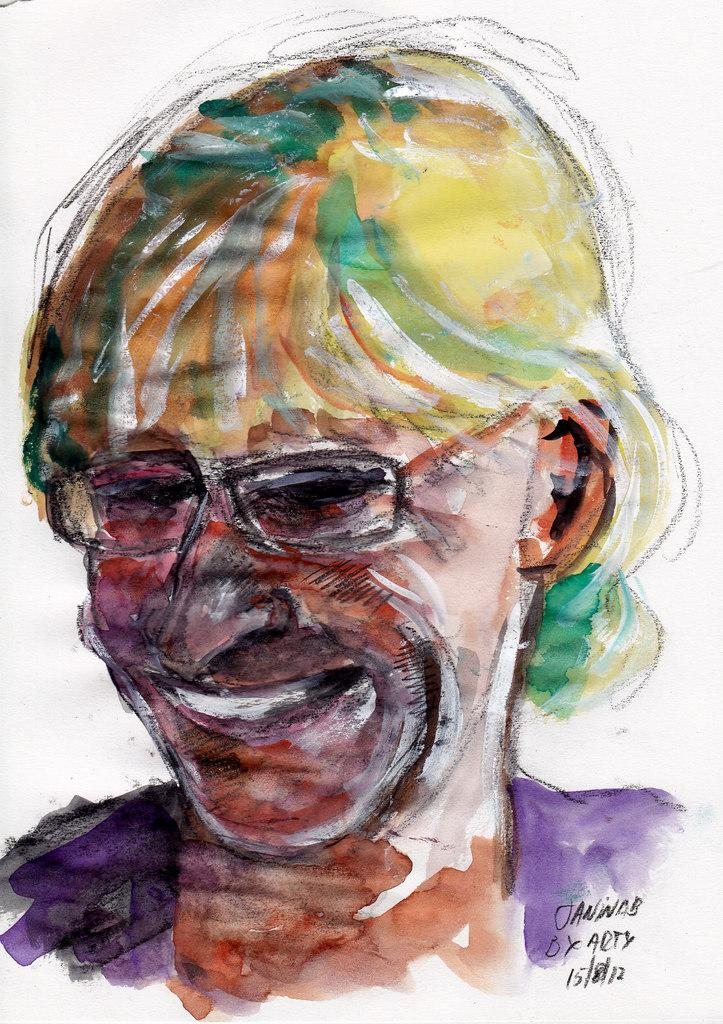What type of artwork is shown in the image? The image is a painting. What is the main subject of the painting? There is a face of a person depicted in the painting. What color is the background of the painting? The background of the painting is white. What type of yam is being used as a cannon in the painting? There is no yam or cannon present in the painting; it depicts a face of a person with a white background. 